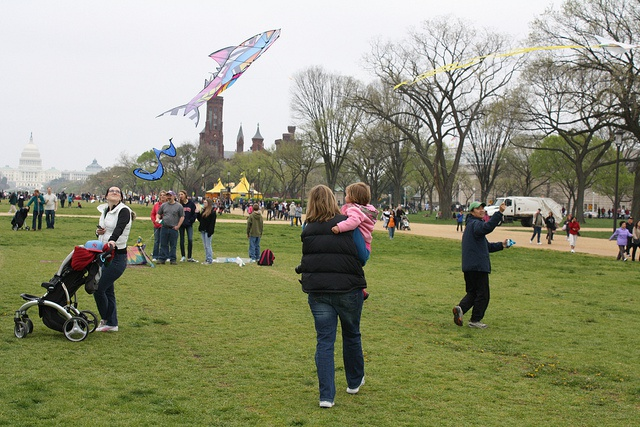Describe the objects in this image and their specific colors. I can see people in white, black, navy, olive, and gray tones, people in white, black, olive, and gray tones, people in white, black, gainsboro, darkgray, and gray tones, kite in white, lavender, lightblue, and darkgray tones, and kite in white, lightgray, darkgray, and khaki tones in this image. 